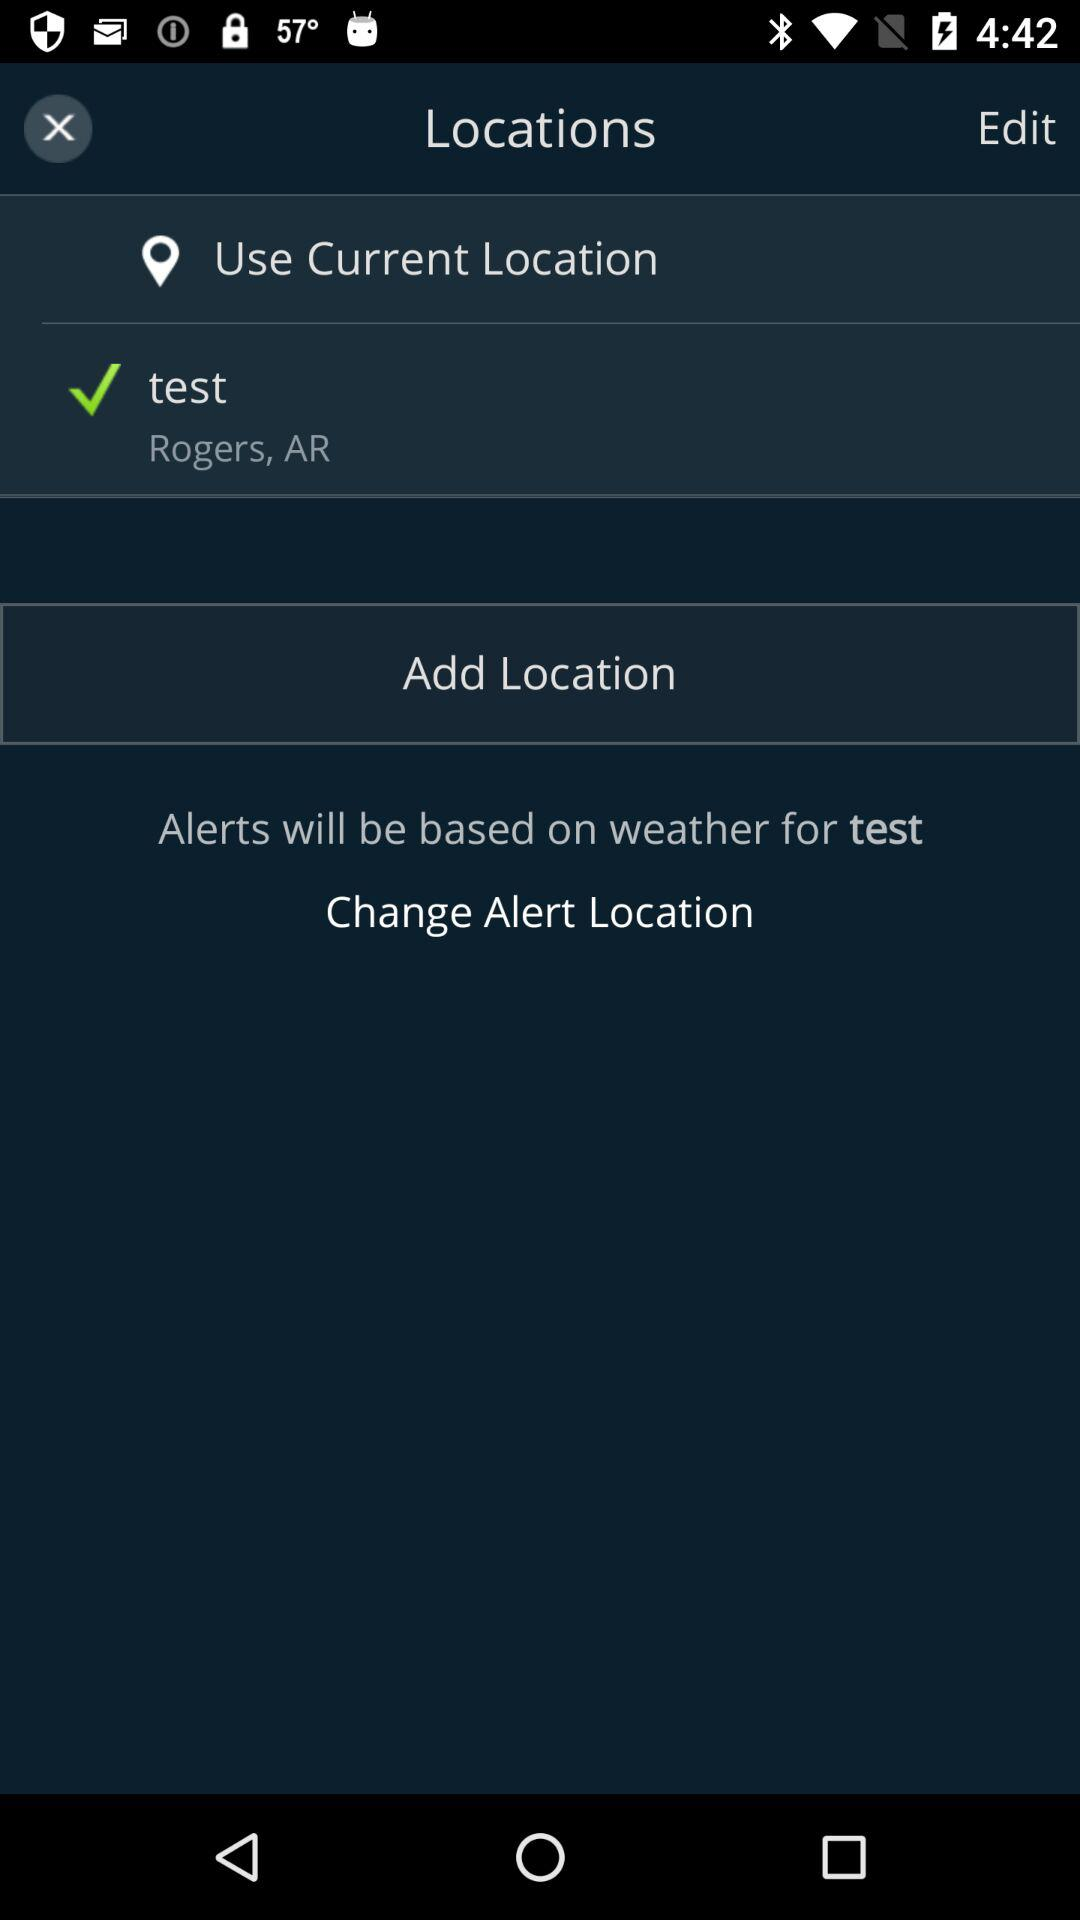What is the current location? The current location is Rogers, AR. 